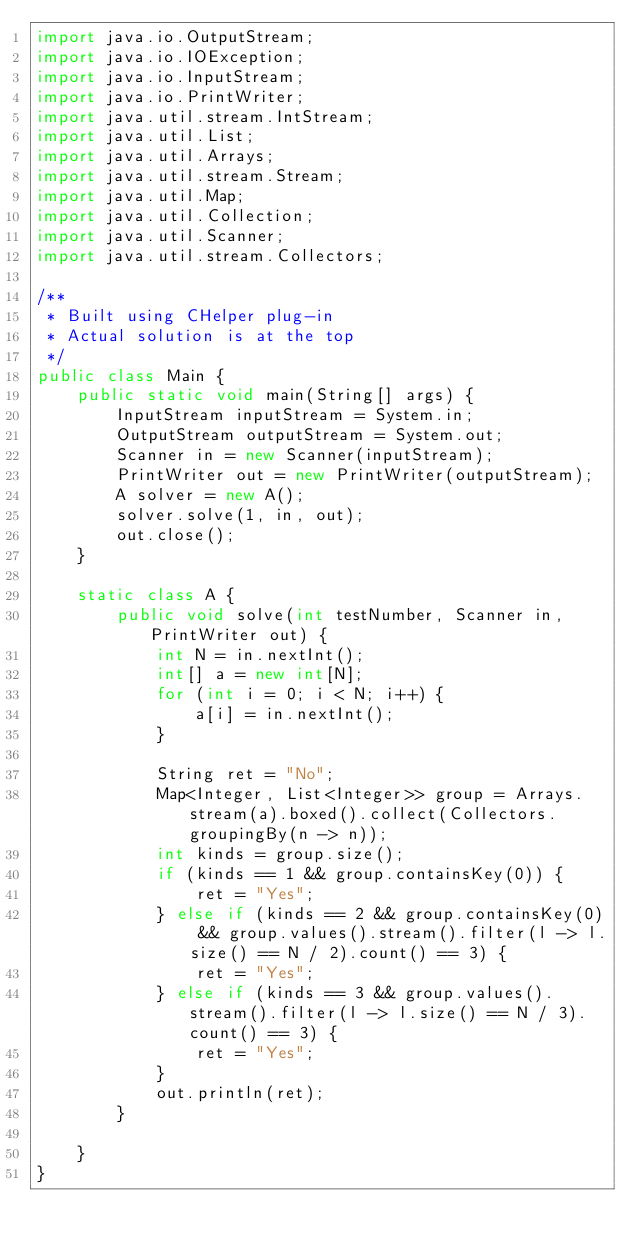<code> <loc_0><loc_0><loc_500><loc_500><_Java_>import java.io.OutputStream;
import java.io.IOException;
import java.io.InputStream;
import java.io.PrintWriter;
import java.util.stream.IntStream;
import java.util.List;
import java.util.Arrays;
import java.util.stream.Stream;
import java.util.Map;
import java.util.Collection;
import java.util.Scanner;
import java.util.stream.Collectors;

/**
 * Built using CHelper plug-in
 * Actual solution is at the top
 */
public class Main {
    public static void main(String[] args) {
        InputStream inputStream = System.in;
        OutputStream outputStream = System.out;
        Scanner in = new Scanner(inputStream);
        PrintWriter out = new PrintWriter(outputStream);
        A solver = new A();
        solver.solve(1, in, out);
        out.close();
    }

    static class A {
        public void solve(int testNumber, Scanner in, PrintWriter out) {
            int N = in.nextInt();
            int[] a = new int[N];
            for (int i = 0; i < N; i++) {
                a[i] = in.nextInt();
            }

            String ret = "No";
            Map<Integer, List<Integer>> group = Arrays.stream(a).boxed().collect(Collectors.groupingBy(n -> n));
            int kinds = group.size();
            if (kinds == 1 && group.containsKey(0)) {
                ret = "Yes";
            } else if (kinds == 2 && group.containsKey(0) && group.values().stream().filter(l -> l.size() == N / 2).count() == 3) {
                ret = "Yes";
            } else if (kinds == 3 && group.values().stream().filter(l -> l.size() == N / 3).count() == 3) {
                ret = "Yes";
            }
            out.println(ret);
        }

    }
}

</code> 